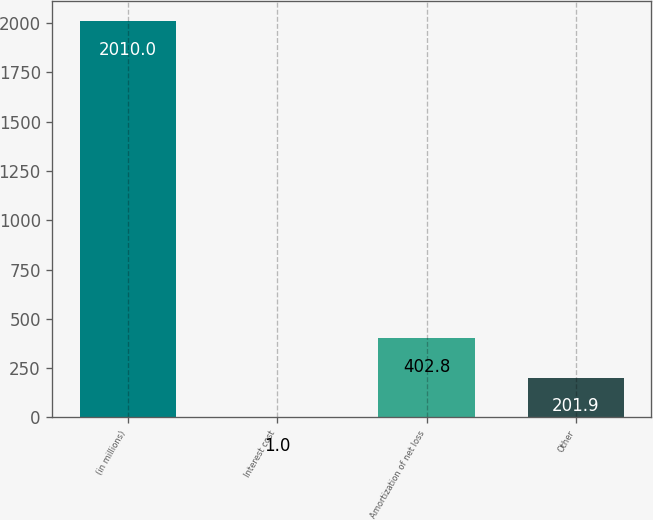Convert chart. <chart><loc_0><loc_0><loc_500><loc_500><bar_chart><fcel>(in millions)<fcel>Interest cost<fcel>Amortization of net loss<fcel>Other<nl><fcel>2010<fcel>1<fcel>402.8<fcel>201.9<nl></chart> 